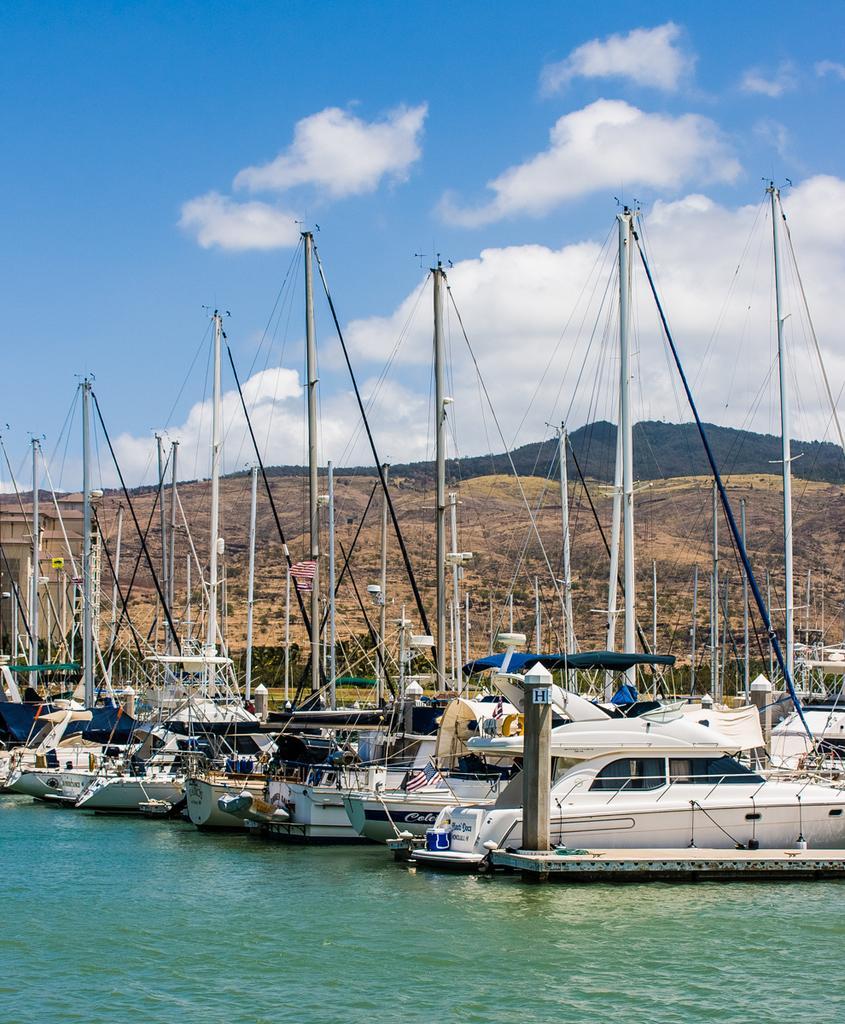Could you give a brief overview of what you see in this image? At the bottom of the image there is water. There is a wooden deck on the water. And also there is a wooden pole on the wooden deck. Behind that there are boats with poles, ropes and some other things. Behind them there are hills. At the top of the image there is sky with clouds. 